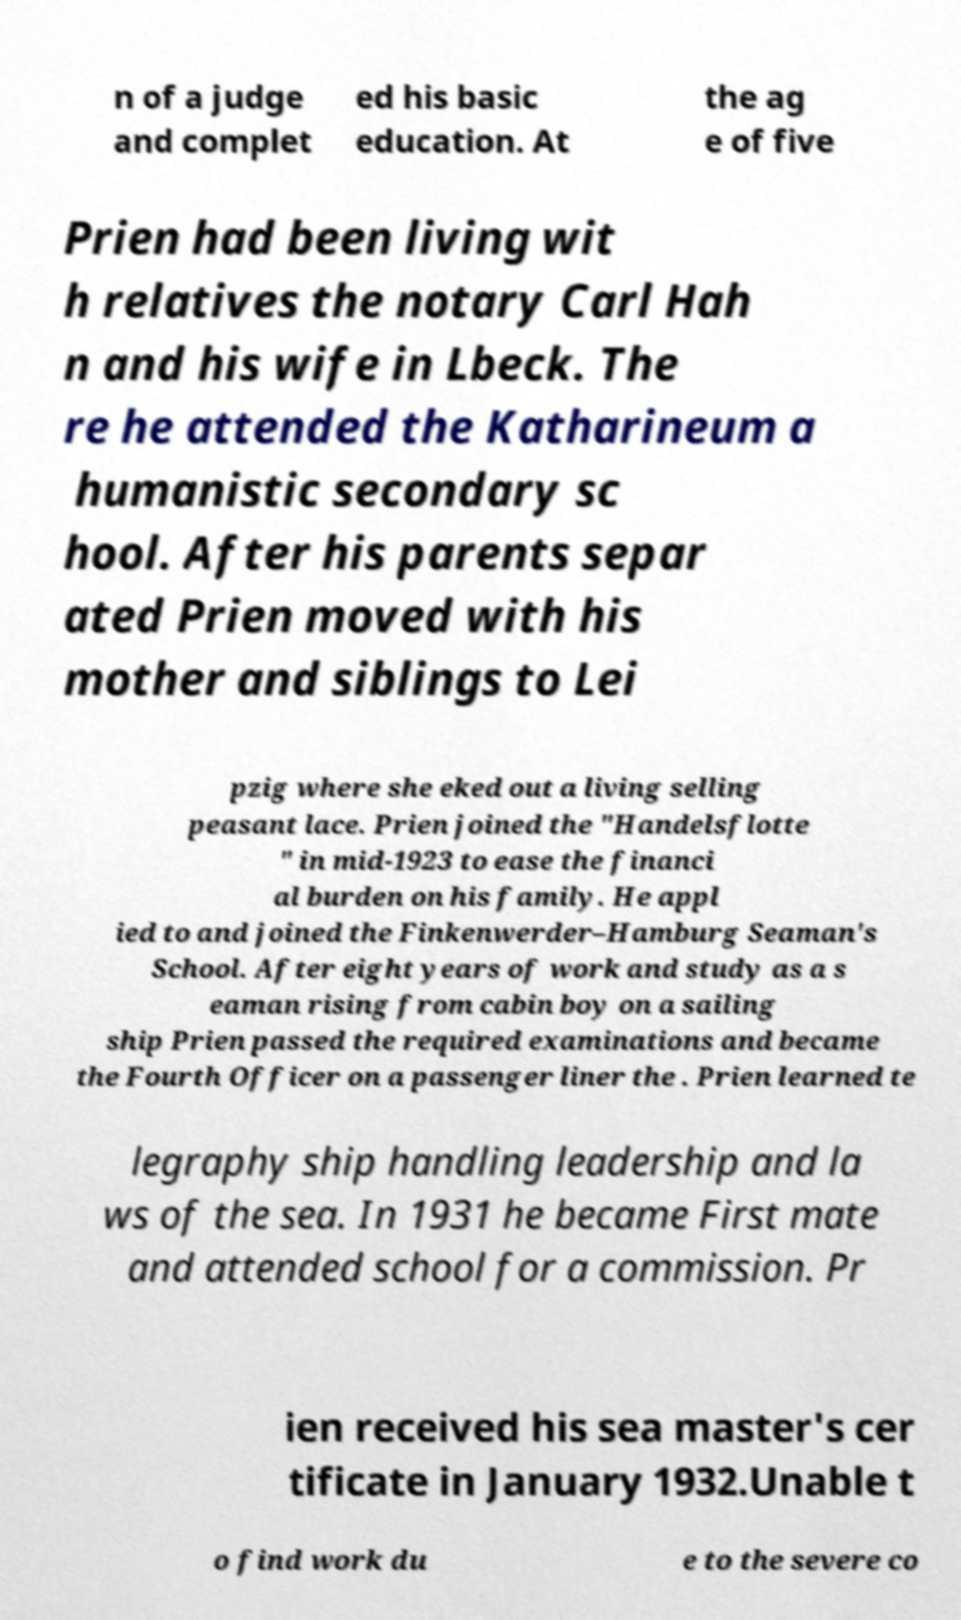I need the written content from this picture converted into text. Can you do that? n of a judge and complet ed his basic education. At the ag e of five Prien had been living wit h relatives the notary Carl Hah n and his wife in Lbeck. The re he attended the Katharineum a humanistic secondary sc hool. After his parents separ ated Prien moved with his mother and siblings to Lei pzig where she eked out a living selling peasant lace. Prien joined the "Handelsflotte " in mid-1923 to ease the financi al burden on his family. He appl ied to and joined the Finkenwerder–Hamburg Seaman's School. After eight years of work and study as a s eaman rising from cabin boy on a sailing ship Prien passed the required examinations and became the Fourth Officer on a passenger liner the . Prien learned te legraphy ship handling leadership and la ws of the sea. In 1931 he became First mate and attended school for a commission. Pr ien received his sea master's cer tificate in January 1932.Unable t o find work du e to the severe co 